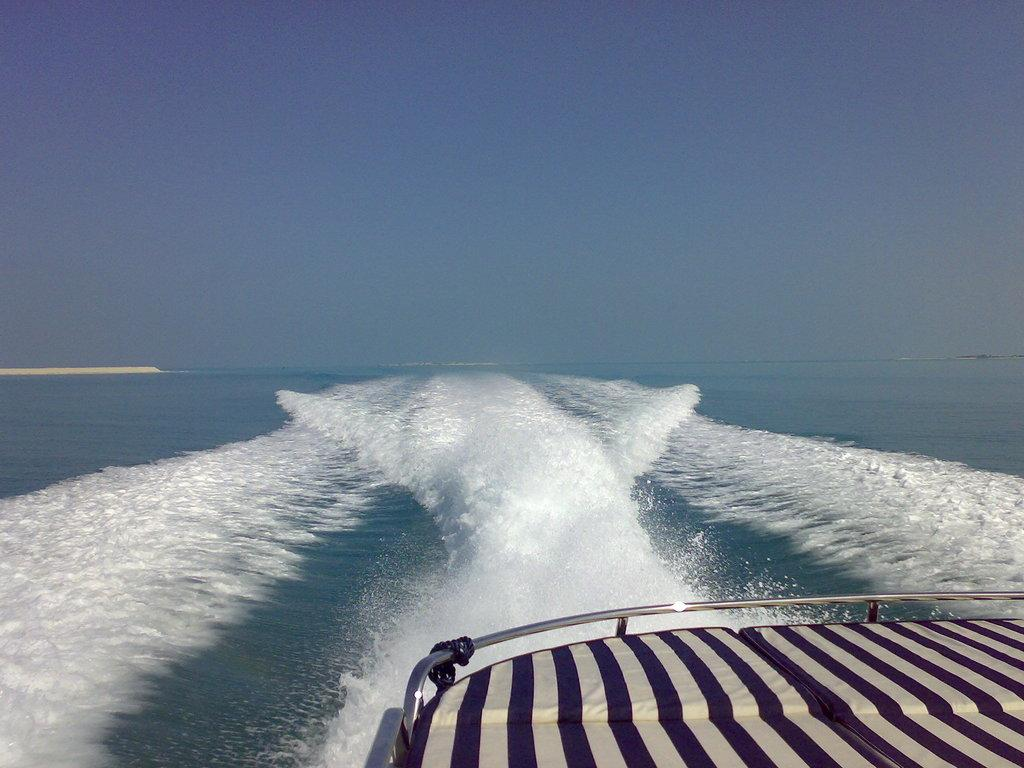What is the main subject of the image? The main subject of the image is a boat. Where is the boat located in the image? The boat is located on the right bottom of the image. What is surrounding the boat in the image? There is water around the boat. What can be seen in the background of the image? The sky is visible in the background of the image. How would you describe the weather based on the sky in the image? The sky appears clear in the image, suggesting good weather. What type of insurance policy is being discussed in the image? There is no indication of an insurance policy being discussed in the image; it features a boat on water with a clear sky in the background. 